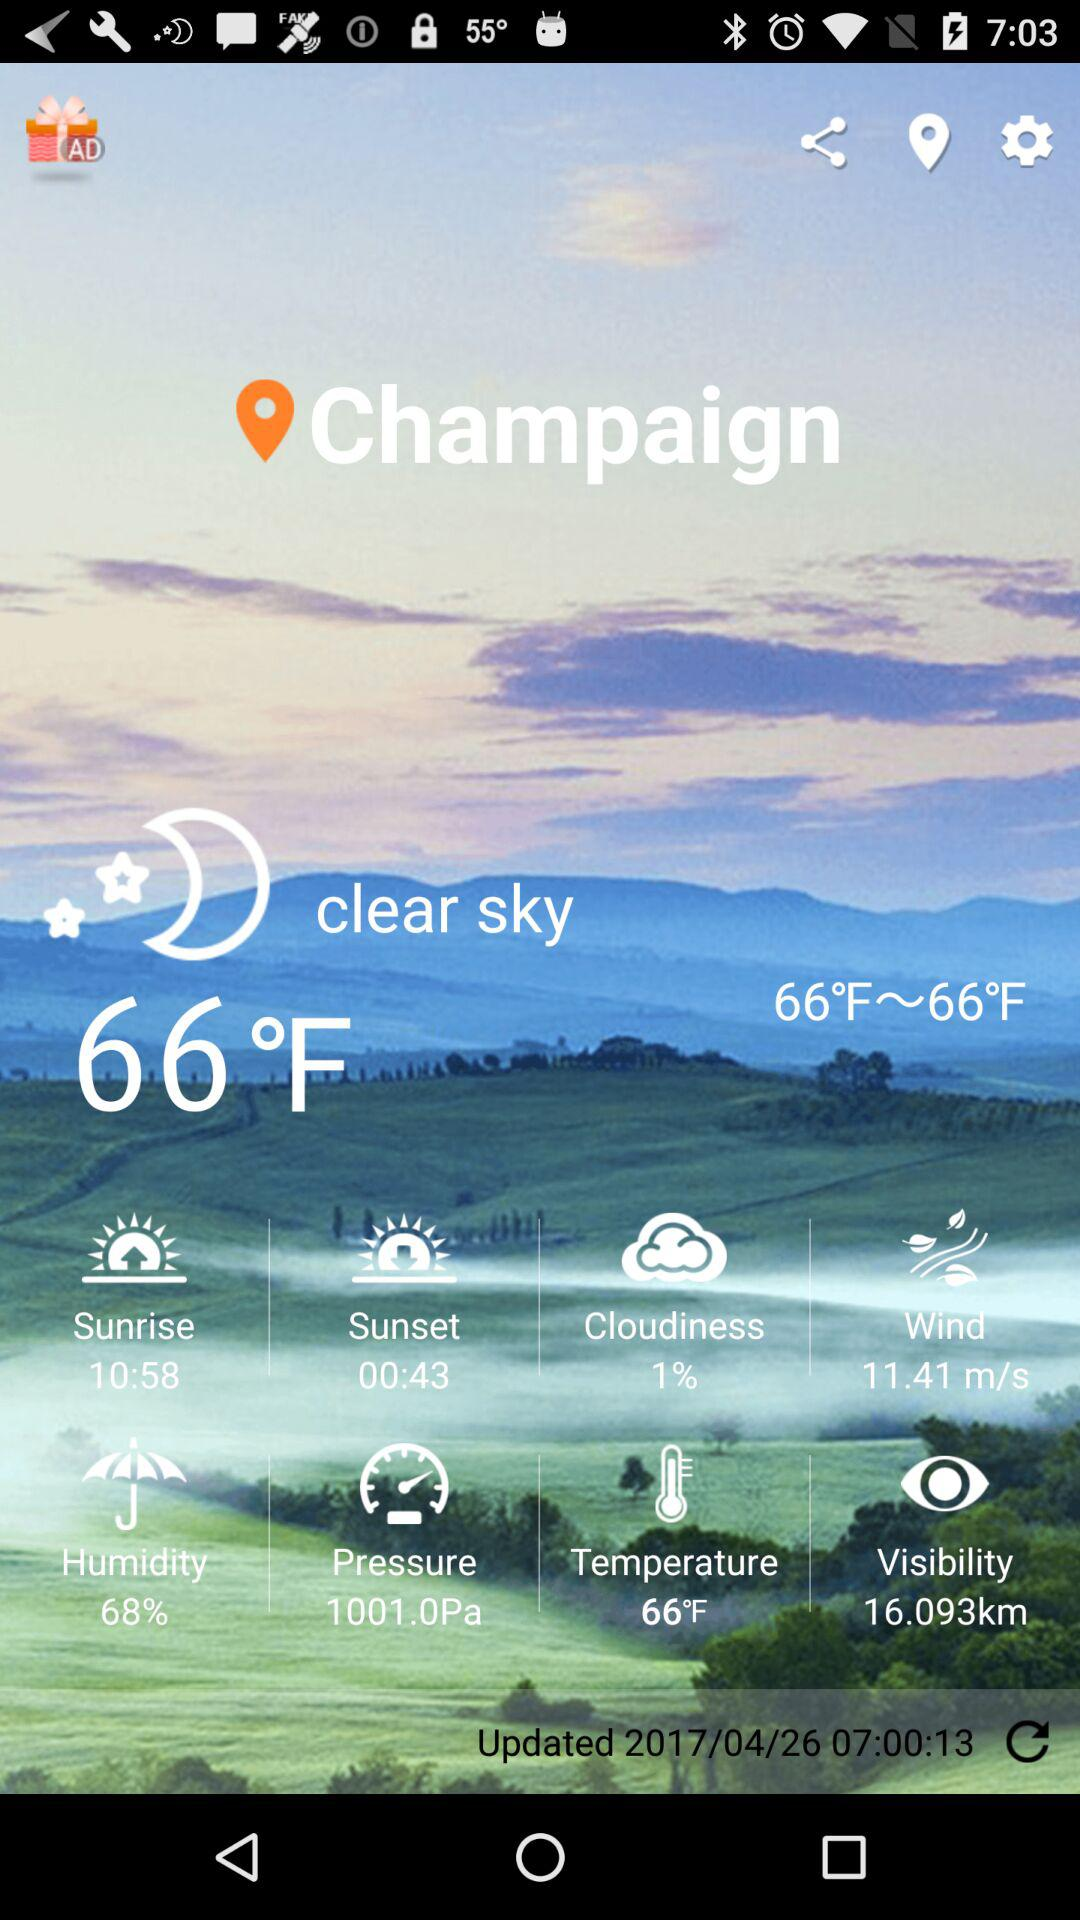What is the temperature? The temperature is 66°F. 